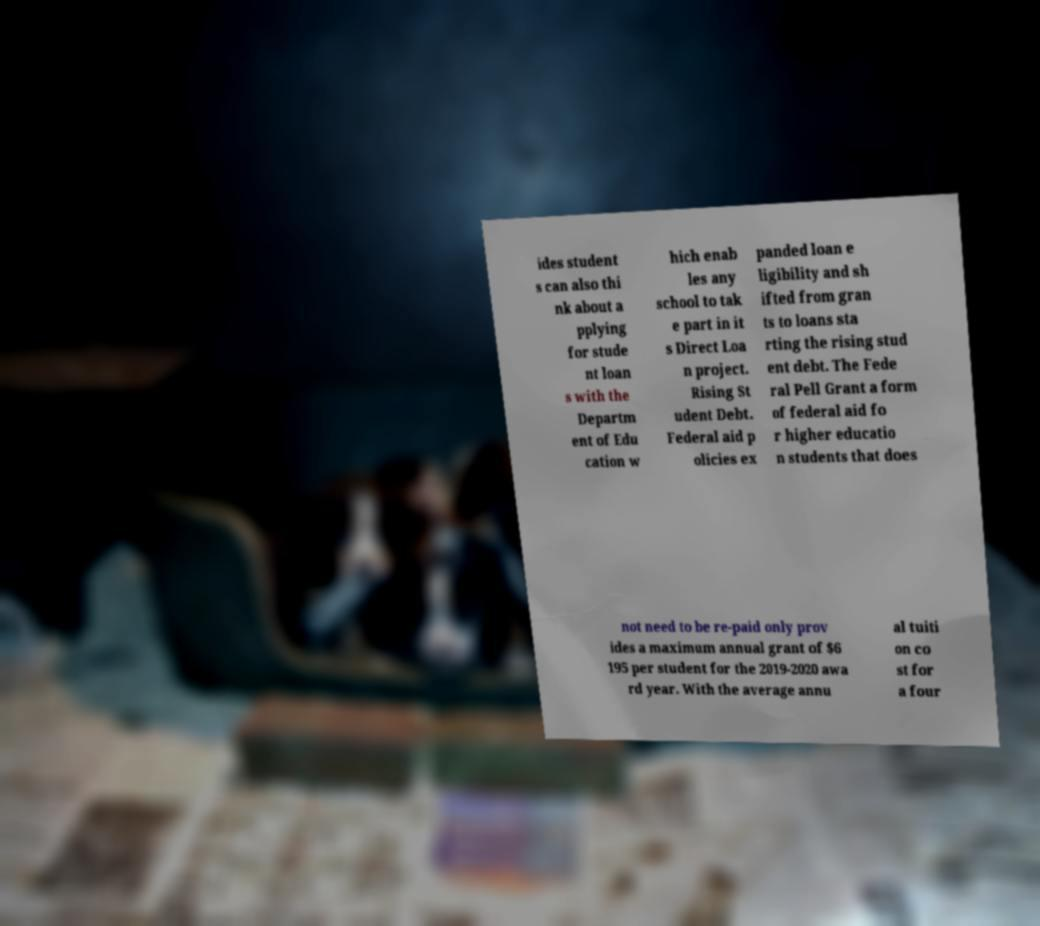What messages or text are displayed in this image? I need them in a readable, typed format. ides student s can also thi nk about a pplying for stude nt loan s with the Departm ent of Edu cation w hich enab les any school to tak e part in it s Direct Loa n project. Rising St udent Debt. Federal aid p olicies ex panded loan e ligibility and sh ifted from gran ts to loans sta rting the rising stud ent debt. The Fede ral Pell Grant a form of federal aid fo r higher educatio n students that does not need to be re-paid only prov ides a maximum annual grant of $6 195 per student for the 2019-2020 awa rd year. With the average annu al tuiti on co st for a four 